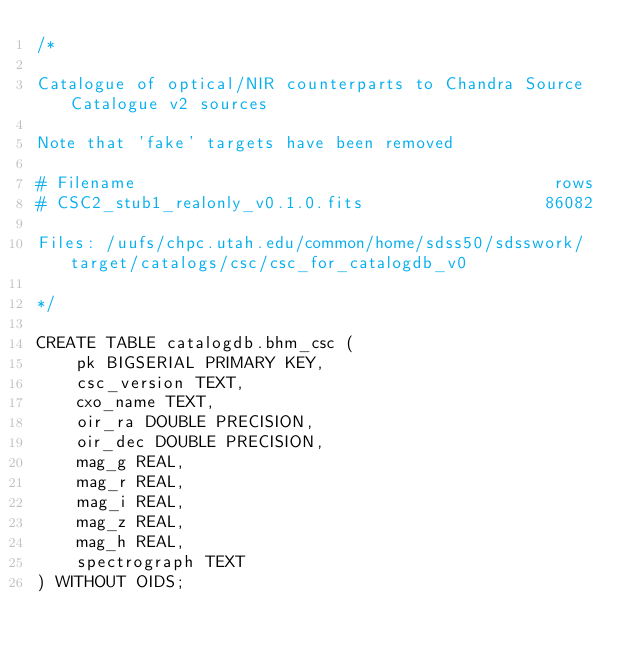Convert code to text. <code><loc_0><loc_0><loc_500><loc_500><_SQL_>/*

Catalogue of optical/NIR counterparts to Chandra Source Catalogue v2 sources

Note that 'fake' targets have been removed

# Filename                                          rows
# CSC2_stub1_realonly_v0.1.0.fits                  86082

Files: /uufs/chpc.utah.edu/common/home/sdss50/sdsswork/target/catalogs/csc/csc_for_catalogdb_v0

*/

CREATE TABLE catalogdb.bhm_csc (
    pk BIGSERIAL PRIMARY KEY,
    csc_version TEXT,
    cxo_name TEXT,
    oir_ra DOUBLE PRECISION,
    oir_dec DOUBLE PRECISION,
    mag_g REAL,
    mag_r REAL,
    mag_i REAL,
    mag_z REAL,
    mag_h REAL,
    spectrograph TEXT
) WITHOUT OIDS;
</code> 